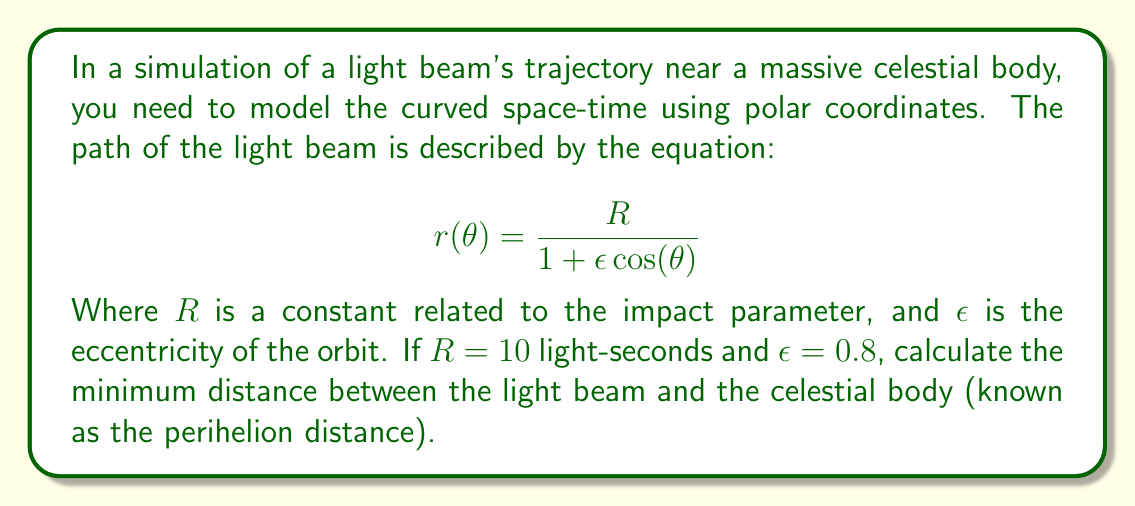What is the answer to this math problem? To solve this problem, we need to follow these steps:

1) The equation given is in the form of a polar conic section. The minimum distance occurs at the perihelion, which is when $\cos(\theta) = 1$.

2) Let's substitute the given values into the equation:

   $$r(\theta) = \frac{10}{1 + 0.8 \cos(\theta)}$$

3) At the perihelion, $\cos(\theta) = 1$, so:

   $$r_{min} = \frac{10}{1 + 0.8(1)} = \frac{10}{1.8}$$

4) Simplify:

   $$r_{min} = \frac{10}{1.8} = \frac{50}{9} \approx 5.56$$

This result is in light-seconds, as that was the unit given for $R$.

The simulation of this trajectory in curved space-time is analogous to how computer scientists might model complex systems with multiple interacting variables. Just as the light beam's path is influenced by the curvature of space-time, algorithms in computer science often need to account for various environmental factors that can alter their behavior.
Answer: The minimum distance (perihelion) is $\frac{50}{9}$ light-seconds or approximately 5.56 light-seconds. 